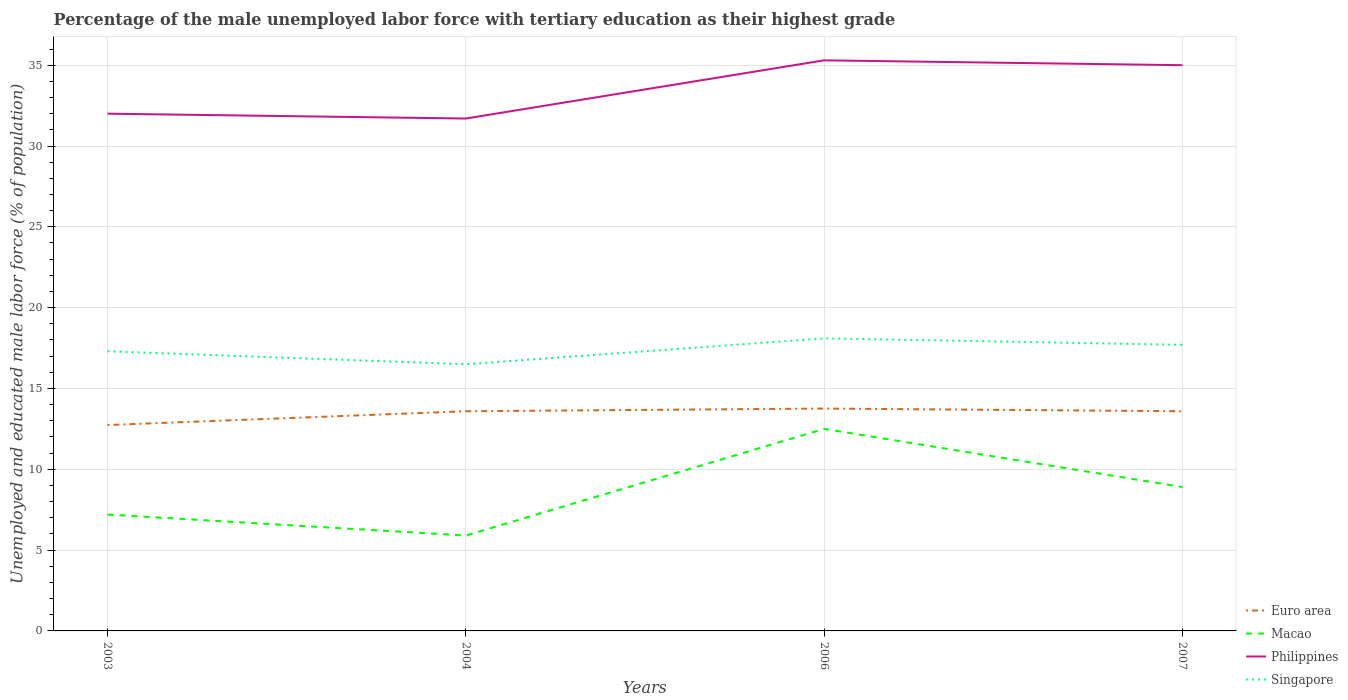How many different coloured lines are there?
Give a very brief answer. 4. Does the line corresponding to Macao intersect with the line corresponding to Singapore?
Your answer should be compact. No. Across all years, what is the maximum percentage of the unemployed male labor force with tertiary education in Philippines?
Provide a succinct answer. 31.7. In which year was the percentage of the unemployed male labor force with tertiary education in Euro area maximum?
Provide a short and direct response. 2003. What is the total percentage of the unemployed male labor force with tertiary education in Macao in the graph?
Your response must be concise. 1.3. What is the difference between the highest and the second highest percentage of the unemployed male labor force with tertiary education in Philippines?
Make the answer very short. 3.6. What is the difference between the highest and the lowest percentage of the unemployed male labor force with tertiary education in Philippines?
Provide a succinct answer. 2. How many years are there in the graph?
Your answer should be compact. 4. Are the values on the major ticks of Y-axis written in scientific E-notation?
Ensure brevity in your answer.  No. Does the graph contain grids?
Make the answer very short. Yes. What is the title of the graph?
Make the answer very short. Percentage of the male unemployed labor force with tertiary education as their highest grade. What is the label or title of the Y-axis?
Make the answer very short. Unemployed and educated male labor force (% of population). What is the Unemployed and educated male labor force (% of population) of Euro area in 2003?
Your response must be concise. 12.74. What is the Unemployed and educated male labor force (% of population) in Macao in 2003?
Give a very brief answer. 7.2. What is the Unemployed and educated male labor force (% of population) in Philippines in 2003?
Give a very brief answer. 32. What is the Unemployed and educated male labor force (% of population) in Singapore in 2003?
Provide a succinct answer. 17.3. What is the Unemployed and educated male labor force (% of population) of Euro area in 2004?
Your answer should be compact. 13.59. What is the Unemployed and educated male labor force (% of population) in Macao in 2004?
Ensure brevity in your answer.  5.9. What is the Unemployed and educated male labor force (% of population) of Philippines in 2004?
Your response must be concise. 31.7. What is the Unemployed and educated male labor force (% of population) in Singapore in 2004?
Give a very brief answer. 16.5. What is the Unemployed and educated male labor force (% of population) in Euro area in 2006?
Give a very brief answer. 13.76. What is the Unemployed and educated male labor force (% of population) of Macao in 2006?
Provide a succinct answer. 12.5. What is the Unemployed and educated male labor force (% of population) of Philippines in 2006?
Ensure brevity in your answer.  35.3. What is the Unemployed and educated male labor force (% of population) of Singapore in 2006?
Ensure brevity in your answer.  18.1. What is the Unemployed and educated male labor force (% of population) in Euro area in 2007?
Give a very brief answer. 13.59. What is the Unemployed and educated male labor force (% of population) in Macao in 2007?
Offer a very short reply. 8.9. What is the Unemployed and educated male labor force (% of population) of Philippines in 2007?
Ensure brevity in your answer.  35. What is the Unemployed and educated male labor force (% of population) in Singapore in 2007?
Provide a short and direct response. 17.7. Across all years, what is the maximum Unemployed and educated male labor force (% of population) of Euro area?
Provide a short and direct response. 13.76. Across all years, what is the maximum Unemployed and educated male labor force (% of population) of Philippines?
Offer a very short reply. 35.3. Across all years, what is the maximum Unemployed and educated male labor force (% of population) of Singapore?
Your answer should be compact. 18.1. Across all years, what is the minimum Unemployed and educated male labor force (% of population) in Euro area?
Provide a short and direct response. 12.74. Across all years, what is the minimum Unemployed and educated male labor force (% of population) in Macao?
Provide a succinct answer. 5.9. Across all years, what is the minimum Unemployed and educated male labor force (% of population) of Philippines?
Make the answer very short. 31.7. What is the total Unemployed and educated male labor force (% of population) of Euro area in the graph?
Your answer should be very brief. 53.68. What is the total Unemployed and educated male labor force (% of population) of Macao in the graph?
Offer a terse response. 34.5. What is the total Unemployed and educated male labor force (% of population) in Philippines in the graph?
Your answer should be compact. 134. What is the total Unemployed and educated male labor force (% of population) in Singapore in the graph?
Provide a short and direct response. 69.6. What is the difference between the Unemployed and educated male labor force (% of population) in Euro area in 2003 and that in 2004?
Make the answer very short. -0.85. What is the difference between the Unemployed and educated male labor force (% of population) of Macao in 2003 and that in 2004?
Your response must be concise. 1.3. What is the difference between the Unemployed and educated male labor force (% of population) of Singapore in 2003 and that in 2004?
Your answer should be compact. 0.8. What is the difference between the Unemployed and educated male labor force (% of population) in Euro area in 2003 and that in 2006?
Keep it short and to the point. -1.02. What is the difference between the Unemployed and educated male labor force (% of population) of Macao in 2003 and that in 2006?
Your response must be concise. -5.3. What is the difference between the Unemployed and educated male labor force (% of population) of Philippines in 2003 and that in 2006?
Your answer should be very brief. -3.3. What is the difference between the Unemployed and educated male labor force (% of population) in Euro area in 2003 and that in 2007?
Your answer should be very brief. -0.85. What is the difference between the Unemployed and educated male labor force (% of population) in Macao in 2003 and that in 2007?
Ensure brevity in your answer.  -1.7. What is the difference between the Unemployed and educated male labor force (% of population) in Philippines in 2003 and that in 2007?
Give a very brief answer. -3. What is the difference between the Unemployed and educated male labor force (% of population) of Singapore in 2003 and that in 2007?
Your answer should be very brief. -0.4. What is the difference between the Unemployed and educated male labor force (% of population) in Euro area in 2004 and that in 2006?
Your answer should be compact. -0.17. What is the difference between the Unemployed and educated male labor force (% of population) of Macao in 2004 and that in 2006?
Offer a very short reply. -6.6. What is the difference between the Unemployed and educated male labor force (% of population) in Euro area in 2004 and that in 2007?
Offer a very short reply. -0. What is the difference between the Unemployed and educated male labor force (% of population) in Macao in 2004 and that in 2007?
Provide a succinct answer. -3. What is the difference between the Unemployed and educated male labor force (% of population) in Euro area in 2006 and that in 2007?
Give a very brief answer. 0.17. What is the difference between the Unemployed and educated male labor force (% of population) in Macao in 2006 and that in 2007?
Your answer should be compact. 3.6. What is the difference between the Unemployed and educated male labor force (% of population) in Euro area in 2003 and the Unemployed and educated male labor force (% of population) in Macao in 2004?
Offer a terse response. 6.84. What is the difference between the Unemployed and educated male labor force (% of population) in Euro area in 2003 and the Unemployed and educated male labor force (% of population) in Philippines in 2004?
Make the answer very short. -18.96. What is the difference between the Unemployed and educated male labor force (% of population) of Euro area in 2003 and the Unemployed and educated male labor force (% of population) of Singapore in 2004?
Offer a very short reply. -3.76. What is the difference between the Unemployed and educated male labor force (% of population) in Macao in 2003 and the Unemployed and educated male labor force (% of population) in Philippines in 2004?
Ensure brevity in your answer.  -24.5. What is the difference between the Unemployed and educated male labor force (% of population) of Macao in 2003 and the Unemployed and educated male labor force (% of population) of Singapore in 2004?
Your answer should be compact. -9.3. What is the difference between the Unemployed and educated male labor force (% of population) in Euro area in 2003 and the Unemployed and educated male labor force (% of population) in Macao in 2006?
Make the answer very short. 0.24. What is the difference between the Unemployed and educated male labor force (% of population) in Euro area in 2003 and the Unemployed and educated male labor force (% of population) in Philippines in 2006?
Offer a terse response. -22.56. What is the difference between the Unemployed and educated male labor force (% of population) in Euro area in 2003 and the Unemployed and educated male labor force (% of population) in Singapore in 2006?
Provide a succinct answer. -5.36. What is the difference between the Unemployed and educated male labor force (% of population) in Macao in 2003 and the Unemployed and educated male labor force (% of population) in Philippines in 2006?
Give a very brief answer. -28.1. What is the difference between the Unemployed and educated male labor force (% of population) of Macao in 2003 and the Unemployed and educated male labor force (% of population) of Singapore in 2006?
Provide a short and direct response. -10.9. What is the difference between the Unemployed and educated male labor force (% of population) in Euro area in 2003 and the Unemployed and educated male labor force (% of population) in Macao in 2007?
Offer a terse response. 3.84. What is the difference between the Unemployed and educated male labor force (% of population) of Euro area in 2003 and the Unemployed and educated male labor force (% of population) of Philippines in 2007?
Your response must be concise. -22.26. What is the difference between the Unemployed and educated male labor force (% of population) of Euro area in 2003 and the Unemployed and educated male labor force (% of population) of Singapore in 2007?
Make the answer very short. -4.96. What is the difference between the Unemployed and educated male labor force (% of population) of Macao in 2003 and the Unemployed and educated male labor force (% of population) of Philippines in 2007?
Your answer should be very brief. -27.8. What is the difference between the Unemployed and educated male labor force (% of population) of Macao in 2003 and the Unemployed and educated male labor force (% of population) of Singapore in 2007?
Provide a succinct answer. -10.5. What is the difference between the Unemployed and educated male labor force (% of population) in Philippines in 2003 and the Unemployed and educated male labor force (% of population) in Singapore in 2007?
Provide a short and direct response. 14.3. What is the difference between the Unemployed and educated male labor force (% of population) of Euro area in 2004 and the Unemployed and educated male labor force (% of population) of Macao in 2006?
Ensure brevity in your answer.  1.09. What is the difference between the Unemployed and educated male labor force (% of population) in Euro area in 2004 and the Unemployed and educated male labor force (% of population) in Philippines in 2006?
Ensure brevity in your answer.  -21.71. What is the difference between the Unemployed and educated male labor force (% of population) in Euro area in 2004 and the Unemployed and educated male labor force (% of population) in Singapore in 2006?
Offer a very short reply. -4.51. What is the difference between the Unemployed and educated male labor force (% of population) in Macao in 2004 and the Unemployed and educated male labor force (% of population) in Philippines in 2006?
Ensure brevity in your answer.  -29.4. What is the difference between the Unemployed and educated male labor force (% of population) in Euro area in 2004 and the Unemployed and educated male labor force (% of population) in Macao in 2007?
Provide a short and direct response. 4.69. What is the difference between the Unemployed and educated male labor force (% of population) in Euro area in 2004 and the Unemployed and educated male labor force (% of population) in Philippines in 2007?
Make the answer very short. -21.41. What is the difference between the Unemployed and educated male labor force (% of population) of Euro area in 2004 and the Unemployed and educated male labor force (% of population) of Singapore in 2007?
Your answer should be compact. -4.11. What is the difference between the Unemployed and educated male labor force (% of population) in Macao in 2004 and the Unemployed and educated male labor force (% of population) in Philippines in 2007?
Your answer should be compact. -29.1. What is the difference between the Unemployed and educated male labor force (% of population) of Macao in 2004 and the Unemployed and educated male labor force (% of population) of Singapore in 2007?
Your answer should be very brief. -11.8. What is the difference between the Unemployed and educated male labor force (% of population) in Euro area in 2006 and the Unemployed and educated male labor force (% of population) in Macao in 2007?
Keep it short and to the point. 4.86. What is the difference between the Unemployed and educated male labor force (% of population) in Euro area in 2006 and the Unemployed and educated male labor force (% of population) in Philippines in 2007?
Give a very brief answer. -21.24. What is the difference between the Unemployed and educated male labor force (% of population) in Euro area in 2006 and the Unemployed and educated male labor force (% of population) in Singapore in 2007?
Your answer should be compact. -3.94. What is the difference between the Unemployed and educated male labor force (% of population) of Macao in 2006 and the Unemployed and educated male labor force (% of population) of Philippines in 2007?
Your answer should be compact. -22.5. What is the average Unemployed and educated male labor force (% of population) of Euro area per year?
Provide a short and direct response. 13.42. What is the average Unemployed and educated male labor force (% of population) in Macao per year?
Provide a short and direct response. 8.62. What is the average Unemployed and educated male labor force (% of population) in Philippines per year?
Make the answer very short. 33.5. What is the average Unemployed and educated male labor force (% of population) of Singapore per year?
Give a very brief answer. 17.4. In the year 2003, what is the difference between the Unemployed and educated male labor force (% of population) in Euro area and Unemployed and educated male labor force (% of population) in Macao?
Keep it short and to the point. 5.54. In the year 2003, what is the difference between the Unemployed and educated male labor force (% of population) in Euro area and Unemployed and educated male labor force (% of population) in Philippines?
Provide a short and direct response. -19.26. In the year 2003, what is the difference between the Unemployed and educated male labor force (% of population) of Euro area and Unemployed and educated male labor force (% of population) of Singapore?
Your answer should be very brief. -4.56. In the year 2003, what is the difference between the Unemployed and educated male labor force (% of population) of Macao and Unemployed and educated male labor force (% of population) of Philippines?
Keep it short and to the point. -24.8. In the year 2003, what is the difference between the Unemployed and educated male labor force (% of population) of Macao and Unemployed and educated male labor force (% of population) of Singapore?
Your answer should be compact. -10.1. In the year 2004, what is the difference between the Unemployed and educated male labor force (% of population) of Euro area and Unemployed and educated male labor force (% of population) of Macao?
Give a very brief answer. 7.69. In the year 2004, what is the difference between the Unemployed and educated male labor force (% of population) of Euro area and Unemployed and educated male labor force (% of population) of Philippines?
Make the answer very short. -18.11. In the year 2004, what is the difference between the Unemployed and educated male labor force (% of population) in Euro area and Unemployed and educated male labor force (% of population) in Singapore?
Give a very brief answer. -2.91. In the year 2004, what is the difference between the Unemployed and educated male labor force (% of population) of Macao and Unemployed and educated male labor force (% of population) of Philippines?
Ensure brevity in your answer.  -25.8. In the year 2004, what is the difference between the Unemployed and educated male labor force (% of population) of Macao and Unemployed and educated male labor force (% of population) of Singapore?
Give a very brief answer. -10.6. In the year 2006, what is the difference between the Unemployed and educated male labor force (% of population) of Euro area and Unemployed and educated male labor force (% of population) of Macao?
Offer a terse response. 1.26. In the year 2006, what is the difference between the Unemployed and educated male labor force (% of population) in Euro area and Unemployed and educated male labor force (% of population) in Philippines?
Make the answer very short. -21.54. In the year 2006, what is the difference between the Unemployed and educated male labor force (% of population) of Euro area and Unemployed and educated male labor force (% of population) of Singapore?
Your answer should be very brief. -4.34. In the year 2006, what is the difference between the Unemployed and educated male labor force (% of population) of Macao and Unemployed and educated male labor force (% of population) of Philippines?
Your answer should be compact. -22.8. In the year 2006, what is the difference between the Unemployed and educated male labor force (% of population) in Macao and Unemployed and educated male labor force (% of population) in Singapore?
Make the answer very short. -5.6. In the year 2006, what is the difference between the Unemployed and educated male labor force (% of population) of Philippines and Unemployed and educated male labor force (% of population) of Singapore?
Ensure brevity in your answer.  17.2. In the year 2007, what is the difference between the Unemployed and educated male labor force (% of population) in Euro area and Unemployed and educated male labor force (% of population) in Macao?
Keep it short and to the point. 4.69. In the year 2007, what is the difference between the Unemployed and educated male labor force (% of population) of Euro area and Unemployed and educated male labor force (% of population) of Philippines?
Your answer should be very brief. -21.41. In the year 2007, what is the difference between the Unemployed and educated male labor force (% of population) of Euro area and Unemployed and educated male labor force (% of population) of Singapore?
Offer a very short reply. -4.11. In the year 2007, what is the difference between the Unemployed and educated male labor force (% of population) in Macao and Unemployed and educated male labor force (% of population) in Philippines?
Ensure brevity in your answer.  -26.1. What is the ratio of the Unemployed and educated male labor force (% of population) of Euro area in 2003 to that in 2004?
Make the answer very short. 0.94. What is the ratio of the Unemployed and educated male labor force (% of population) of Macao in 2003 to that in 2004?
Provide a short and direct response. 1.22. What is the ratio of the Unemployed and educated male labor force (% of population) in Philippines in 2003 to that in 2004?
Provide a succinct answer. 1.01. What is the ratio of the Unemployed and educated male labor force (% of population) of Singapore in 2003 to that in 2004?
Ensure brevity in your answer.  1.05. What is the ratio of the Unemployed and educated male labor force (% of population) of Euro area in 2003 to that in 2006?
Ensure brevity in your answer.  0.93. What is the ratio of the Unemployed and educated male labor force (% of population) in Macao in 2003 to that in 2006?
Offer a very short reply. 0.58. What is the ratio of the Unemployed and educated male labor force (% of population) of Philippines in 2003 to that in 2006?
Provide a succinct answer. 0.91. What is the ratio of the Unemployed and educated male labor force (% of population) of Singapore in 2003 to that in 2006?
Give a very brief answer. 0.96. What is the ratio of the Unemployed and educated male labor force (% of population) in Euro area in 2003 to that in 2007?
Your answer should be very brief. 0.94. What is the ratio of the Unemployed and educated male labor force (% of population) in Macao in 2003 to that in 2007?
Your response must be concise. 0.81. What is the ratio of the Unemployed and educated male labor force (% of population) of Philippines in 2003 to that in 2007?
Provide a short and direct response. 0.91. What is the ratio of the Unemployed and educated male labor force (% of population) in Singapore in 2003 to that in 2007?
Keep it short and to the point. 0.98. What is the ratio of the Unemployed and educated male labor force (% of population) of Euro area in 2004 to that in 2006?
Provide a succinct answer. 0.99. What is the ratio of the Unemployed and educated male labor force (% of population) of Macao in 2004 to that in 2006?
Offer a terse response. 0.47. What is the ratio of the Unemployed and educated male labor force (% of population) in Philippines in 2004 to that in 2006?
Offer a very short reply. 0.9. What is the ratio of the Unemployed and educated male labor force (% of population) in Singapore in 2004 to that in 2006?
Offer a very short reply. 0.91. What is the ratio of the Unemployed and educated male labor force (% of population) of Euro area in 2004 to that in 2007?
Make the answer very short. 1. What is the ratio of the Unemployed and educated male labor force (% of population) of Macao in 2004 to that in 2007?
Offer a terse response. 0.66. What is the ratio of the Unemployed and educated male labor force (% of population) of Philippines in 2004 to that in 2007?
Give a very brief answer. 0.91. What is the ratio of the Unemployed and educated male labor force (% of population) in Singapore in 2004 to that in 2007?
Keep it short and to the point. 0.93. What is the ratio of the Unemployed and educated male labor force (% of population) of Euro area in 2006 to that in 2007?
Ensure brevity in your answer.  1.01. What is the ratio of the Unemployed and educated male labor force (% of population) in Macao in 2006 to that in 2007?
Your answer should be compact. 1.4. What is the ratio of the Unemployed and educated male labor force (% of population) in Philippines in 2006 to that in 2007?
Make the answer very short. 1.01. What is the ratio of the Unemployed and educated male labor force (% of population) in Singapore in 2006 to that in 2007?
Ensure brevity in your answer.  1.02. What is the difference between the highest and the second highest Unemployed and educated male labor force (% of population) in Euro area?
Provide a short and direct response. 0.17. What is the difference between the highest and the lowest Unemployed and educated male labor force (% of population) in Euro area?
Offer a terse response. 1.02. What is the difference between the highest and the lowest Unemployed and educated male labor force (% of population) of Macao?
Your answer should be compact. 6.6. What is the difference between the highest and the lowest Unemployed and educated male labor force (% of population) in Singapore?
Give a very brief answer. 1.6. 